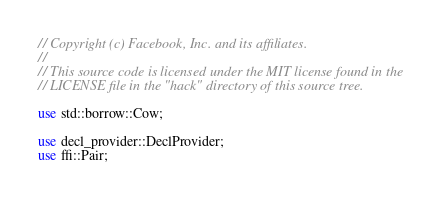Convert code to text. <code><loc_0><loc_0><loc_500><loc_500><_Rust_>// Copyright (c) Facebook, Inc. and its affiliates.
//
// This source code is licensed under the MIT license found in the
// LICENSE file in the "hack" directory of this source tree.

use std::borrow::Cow;

use decl_provider::DeclProvider;
use ffi::Pair;</code> 